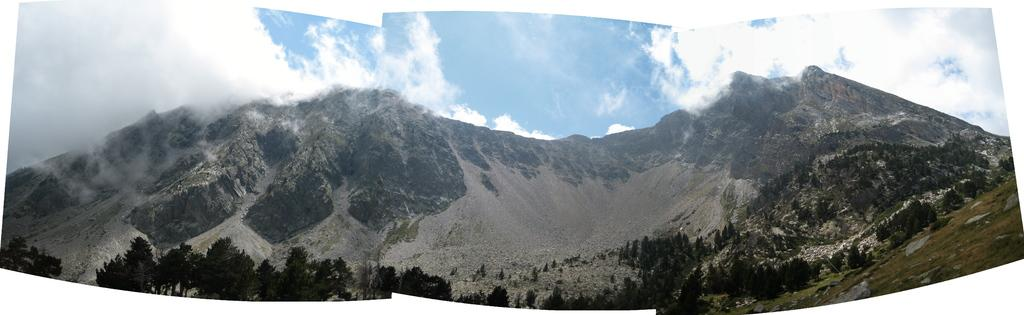What type of natural elements can be seen in the image? There are trees and mountains in the image. What is visible in the sky at the top of the image? There are clouds in the sky at the top of the image. What type of scent can be detected from the trees in the image? There is no information about the scent of the trees in the image, as we are only given visual information. 